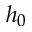Convert formula to latex. <formula><loc_0><loc_0><loc_500><loc_500>h _ { 0 }</formula> 